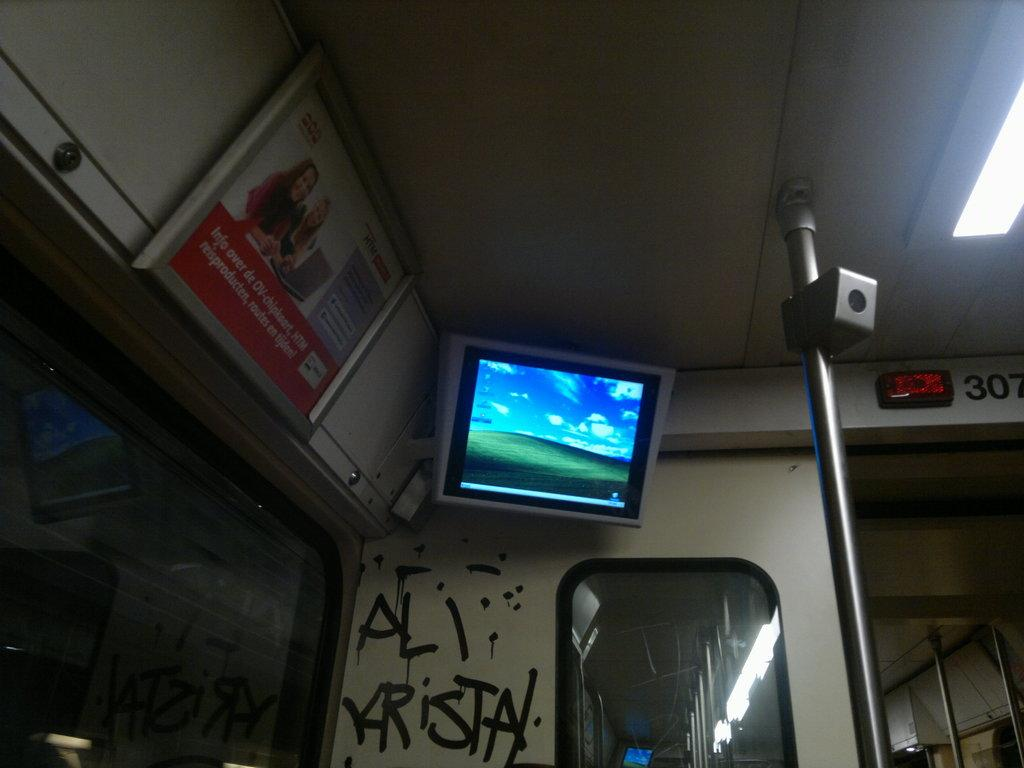<image>
Describe the image concisely. Computer monitor hanging in the corner above some grafitti saying "Ali Krista". 